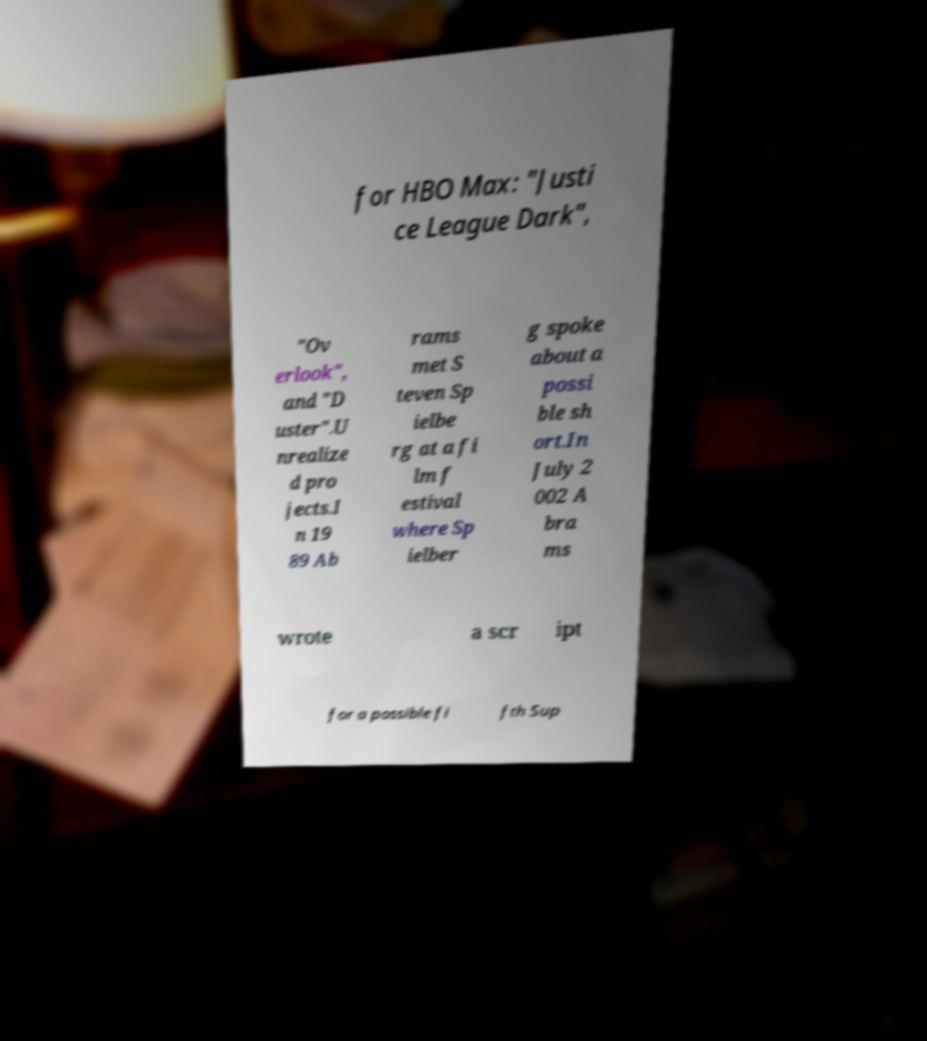What messages or text are displayed in this image? I need them in a readable, typed format. for HBO Max: "Justi ce League Dark", "Ov erlook", and "D uster".U nrealize d pro jects.I n 19 89 Ab rams met S teven Sp ielbe rg at a fi lm f estival where Sp ielber g spoke about a possi ble sh ort.In July 2 002 A bra ms wrote a scr ipt for a possible fi fth Sup 